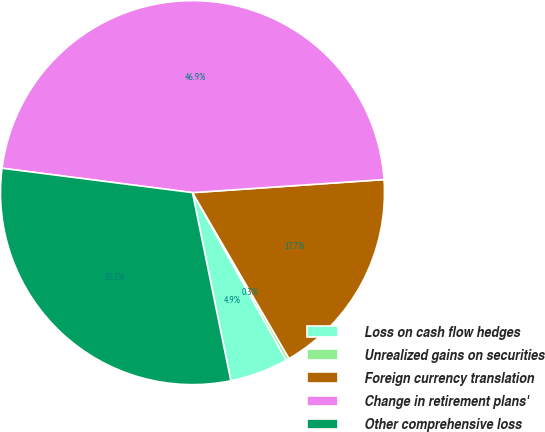Convert chart. <chart><loc_0><loc_0><loc_500><loc_500><pie_chart><fcel>Loss on cash flow hedges<fcel>Unrealized gains on securities<fcel>Foreign currency translation<fcel>Change in retirement plans'<fcel>Other comprehensive loss<nl><fcel>4.92%<fcel>0.26%<fcel>17.7%<fcel>46.89%<fcel>30.23%<nl></chart> 